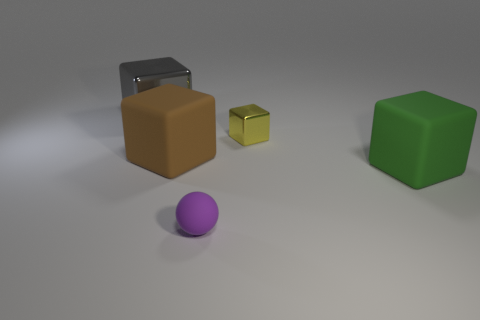Subtract all red blocks. Subtract all brown cylinders. How many blocks are left? 4 Add 1 tiny shiny objects. How many objects exist? 6 Subtract all balls. How many objects are left? 4 Subtract 1 green blocks. How many objects are left? 4 Subtract all large gray metal objects. Subtract all metallic blocks. How many objects are left? 2 Add 1 metallic cubes. How many metallic cubes are left? 3 Add 2 large red matte cubes. How many large red matte cubes exist? 2 